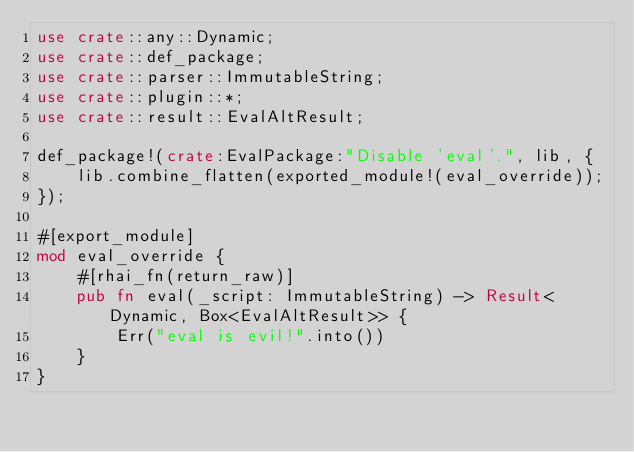Convert code to text. <code><loc_0><loc_0><loc_500><loc_500><_Rust_>use crate::any::Dynamic;
use crate::def_package;
use crate::parser::ImmutableString;
use crate::plugin::*;
use crate::result::EvalAltResult;

def_package!(crate:EvalPackage:"Disable 'eval'.", lib, {
    lib.combine_flatten(exported_module!(eval_override));
});

#[export_module]
mod eval_override {
    #[rhai_fn(return_raw)]
    pub fn eval(_script: ImmutableString) -> Result<Dynamic, Box<EvalAltResult>> {
        Err("eval is evil!".into())
    }
}
</code> 